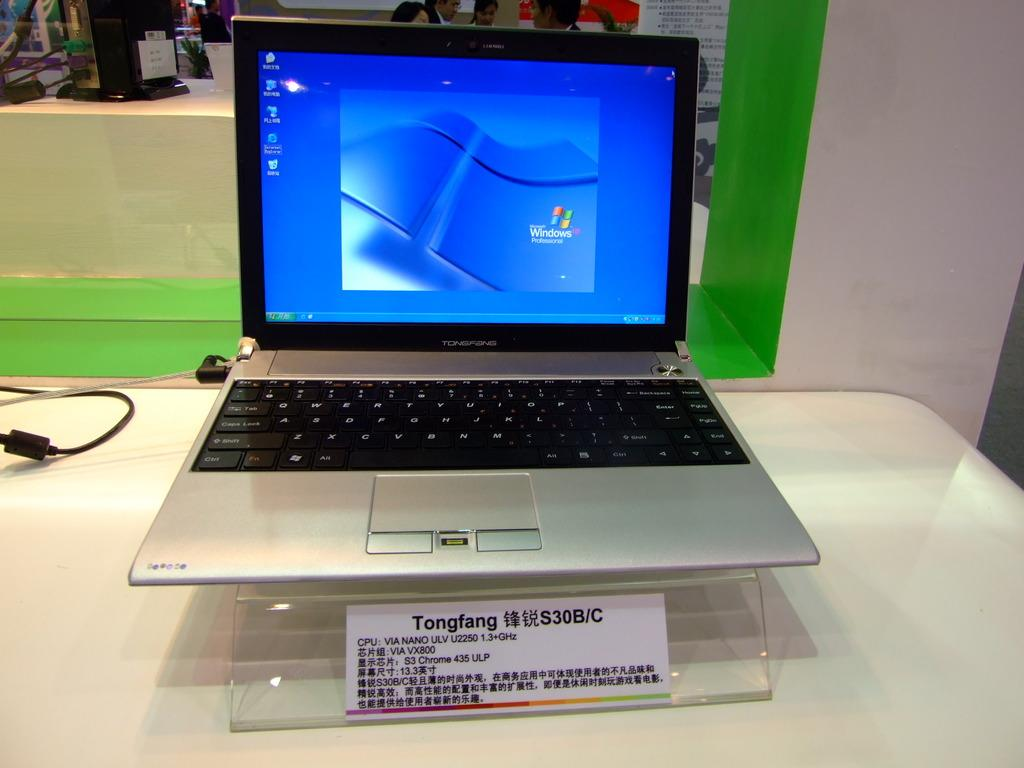<image>
Write a terse but informative summary of the picture. A Tongfang laptop computer is displaying the Windows operating system. 